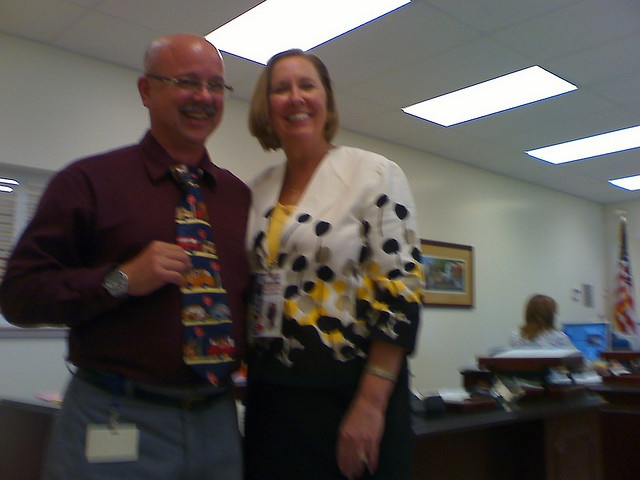Describe the objects in this image and their specific colors. I can see people in gray, black, maroon, and brown tones, people in gray, black, maroon, and darkgray tones, tie in gray, black, maroon, and olive tones, people in gray, black, and darkgray tones, and tv in gray, blue, and darkblue tones in this image. 